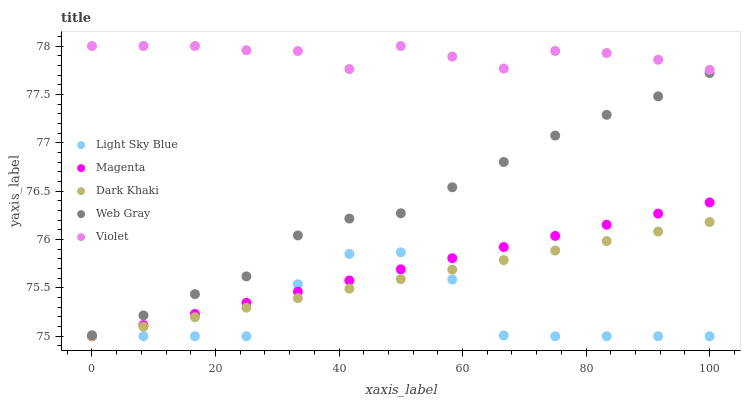Does Light Sky Blue have the minimum area under the curve?
Answer yes or no. Yes. Does Violet have the maximum area under the curve?
Answer yes or no. Yes. Does Magenta have the minimum area under the curve?
Answer yes or no. No. Does Magenta have the maximum area under the curve?
Answer yes or no. No. Is Dark Khaki the smoothest?
Answer yes or no. Yes. Is Light Sky Blue the roughest?
Answer yes or no. Yes. Is Magenta the smoothest?
Answer yes or no. No. Is Magenta the roughest?
Answer yes or no. No. Does Dark Khaki have the lowest value?
Answer yes or no. Yes. Does Web Gray have the lowest value?
Answer yes or no. No. Does Violet have the highest value?
Answer yes or no. Yes. Does Magenta have the highest value?
Answer yes or no. No. Is Web Gray less than Violet?
Answer yes or no. Yes. Is Violet greater than Web Gray?
Answer yes or no. Yes. Does Light Sky Blue intersect Magenta?
Answer yes or no. Yes. Is Light Sky Blue less than Magenta?
Answer yes or no. No. Is Light Sky Blue greater than Magenta?
Answer yes or no. No. Does Web Gray intersect Violet?
Answer yes or no. No. 